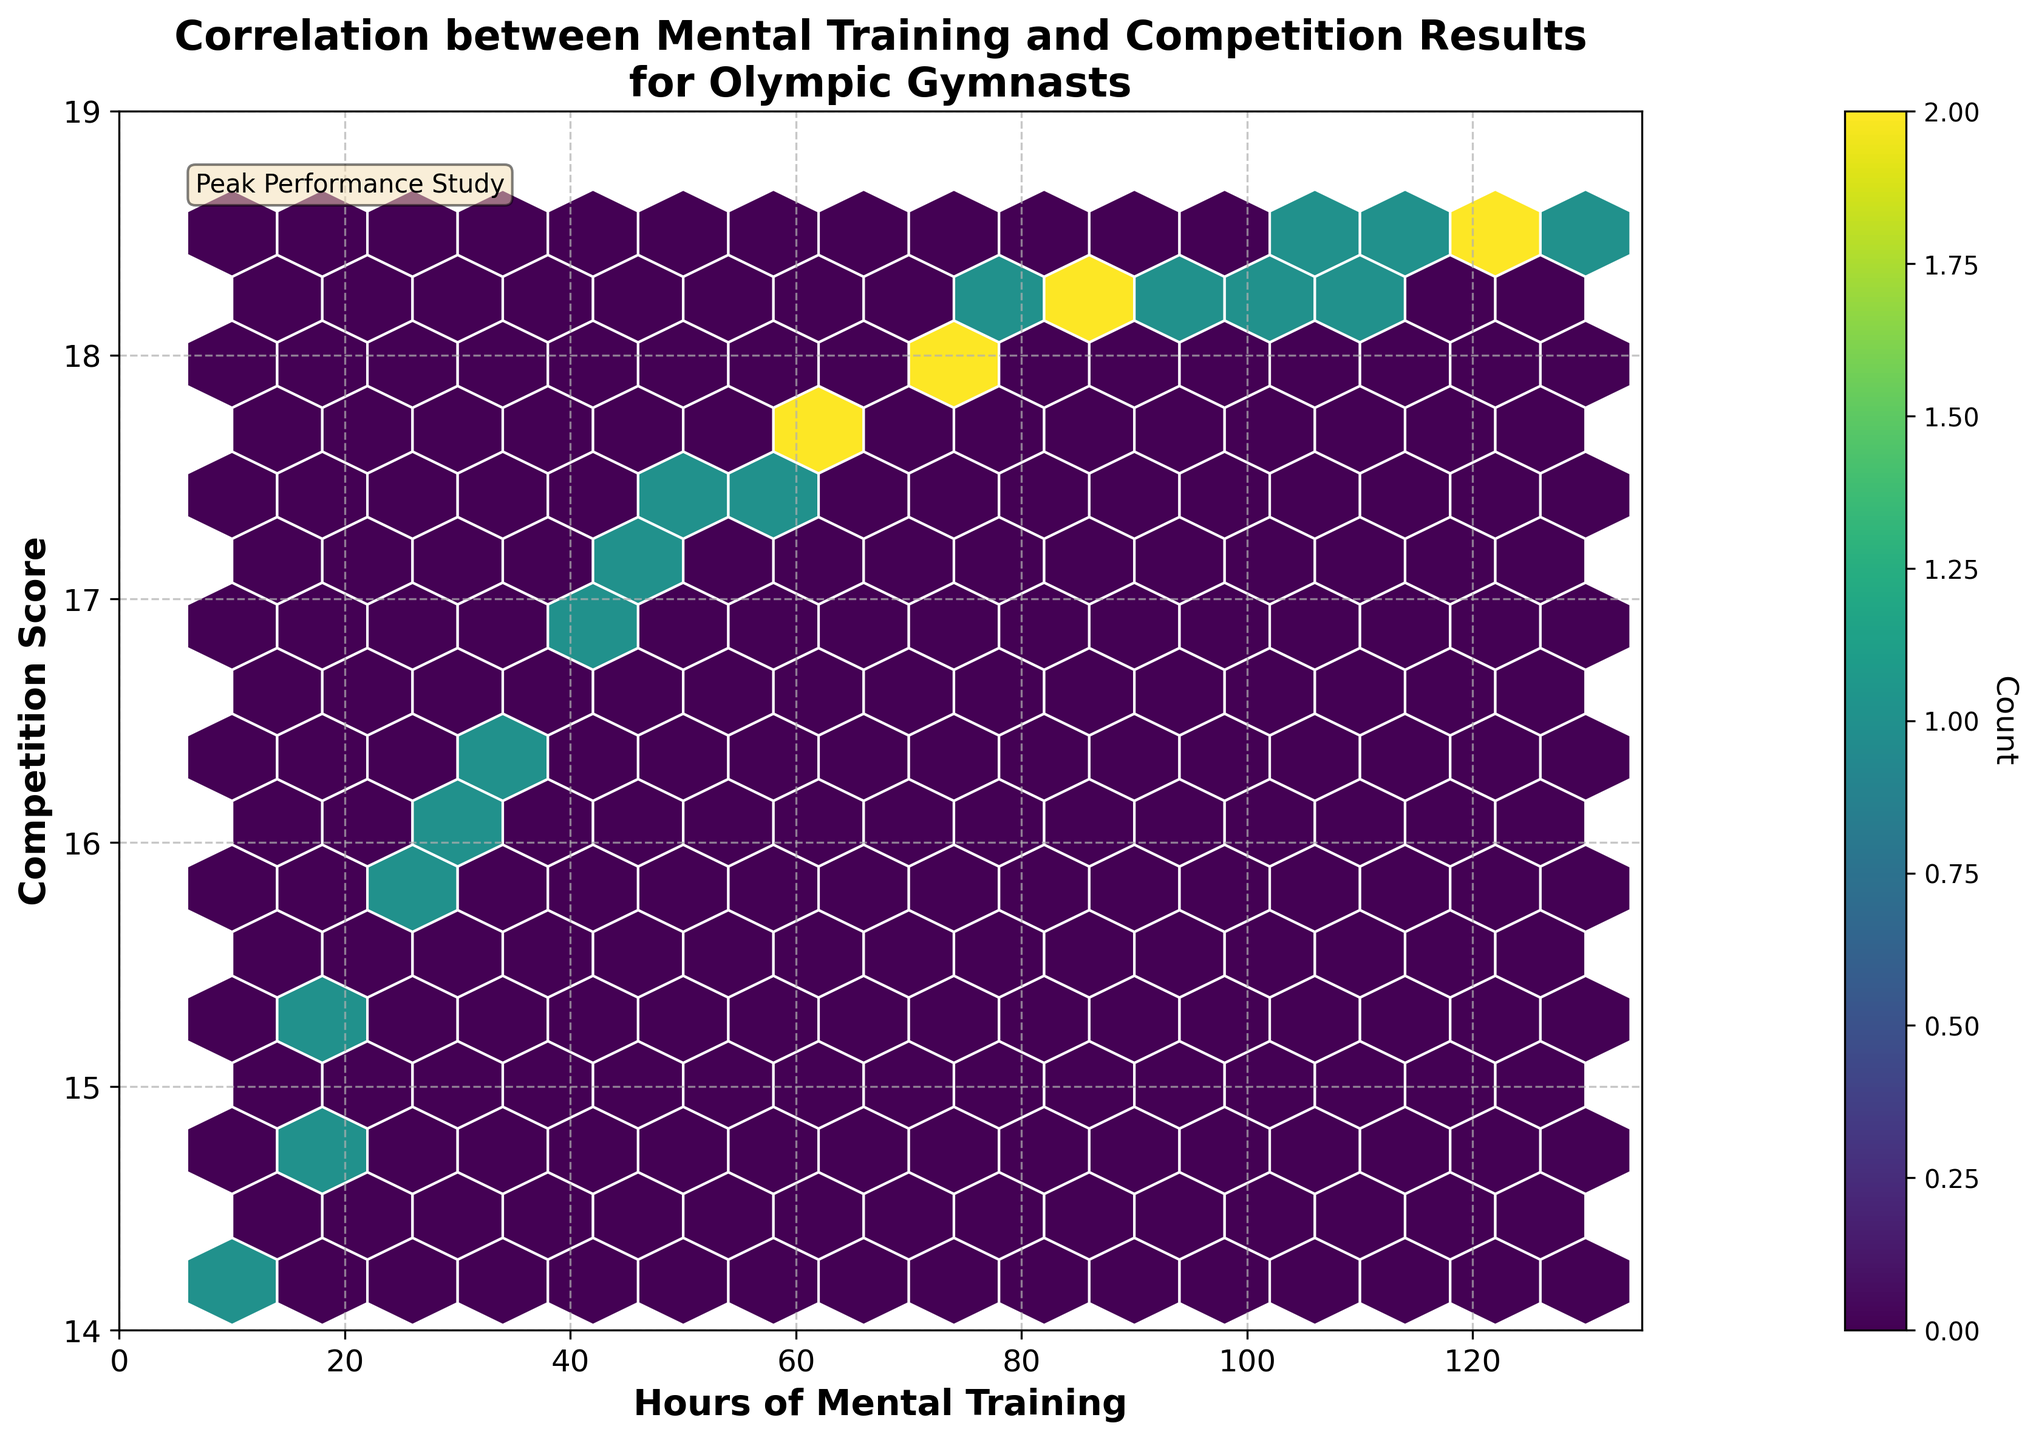what is the title of the plot? The title of the plot is written at the top center of the figure to indicate what the data visualization is about.
Answer: Correlation between Mental Training and Competition Results for Olympic Gymnasts what range of hours of mental training is shown on the x-axis? The x-axis represents the hours of mental training, and you can see the scale at the bottom of the plot, which provides the range.
Answer: 0 to 135 what range of competition scores is shown on the y-axis? The y-axis shows the competition scores, and you can see the scale along the left side of the plot, which details the range of scores.
Answer: 14 to 19 how does the number of hours spent on mental training appear to correlate with competition scores? By examining the trend where the hexbin density increases as you move from left to right and bottom to top on the plot, there appears to be a positive correlation.
Answer: Positive correlation what does the color intensity in the hexbin plot represent? The color intensity of the hexbin plot, as explained by the color bar, represents the count or density of data points within each hexbin.
Answer: Density of data points which range of mental training hours has the highest density of gymnasts? Observing the color intensity and density of the hexagons in the plot, we note the brightest area.
Answer: 60 to 80 hours how many hexagons on average does a grid size of 15 create? By visual inspection, it appears that the plot is divided into hexagons based on the grid size of 15, and you can roughly count them.
Answer: Approximately 225 what is the competition score range for gymnasts with 100 to 120 hours of mental training? Identify the hexbins corresponding to the 100 to 120 hours range on the x-axis and note the y-axis range they span.
Answer: 18.3 to 18.5 does the plot show any gymnasts with less than 20 hours of mental training and a score greater than 15? Check the hexbins corresponding to less than 20 hours on the x-axis and see if any extend above the 15 score line on the y-axis.
Answer: Yes how does the average competition score change from 10 to 130 hours of mental training? Observing the y-values as you move from 10 to 130 hours on the x-axis, there is a noticeable upward trend, indicating that the average score increases.
Answer: Increases 